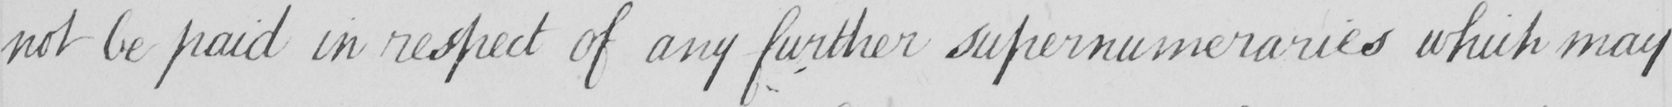What is written in this line of handwriting? not be paid in respect of any further supernumeraries which may 